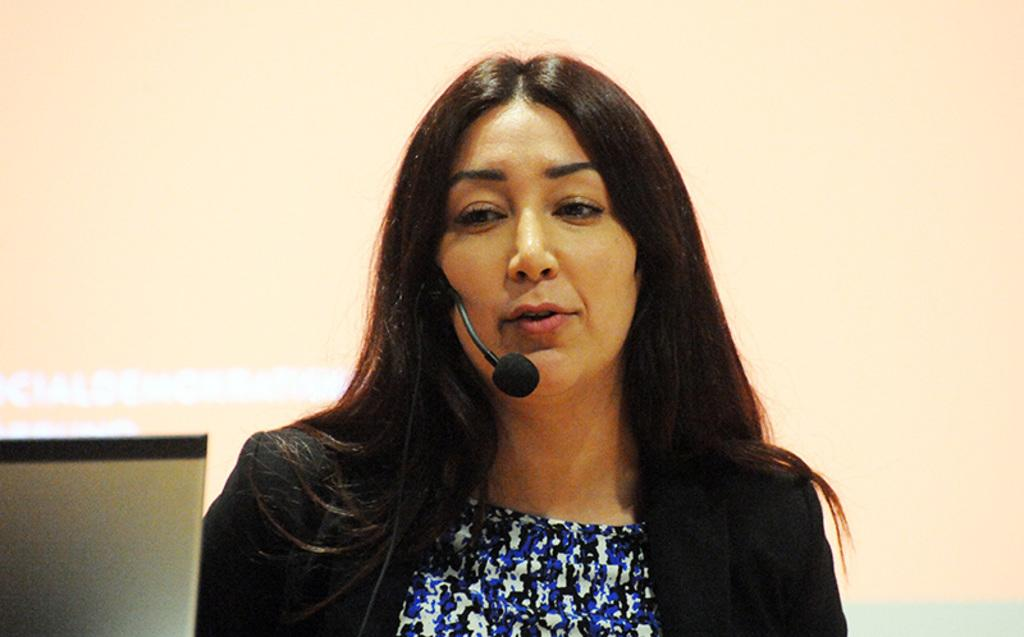What can be seen in the image? There is a person in the image. What object is the person holding? The person is holding a microphone. What else is visible in the image? There is a wire visible in the image. What is located on the left side of the image? There is an object on the left side of the image. What is behind the person in the image? There is a screen behind the person in the image. Can you see a rose on the person's lapel in the image? There is no rose visible on the person's lapel in the image. What observation can be made about the person's father in the image? There is no information about the person's father in the image. 